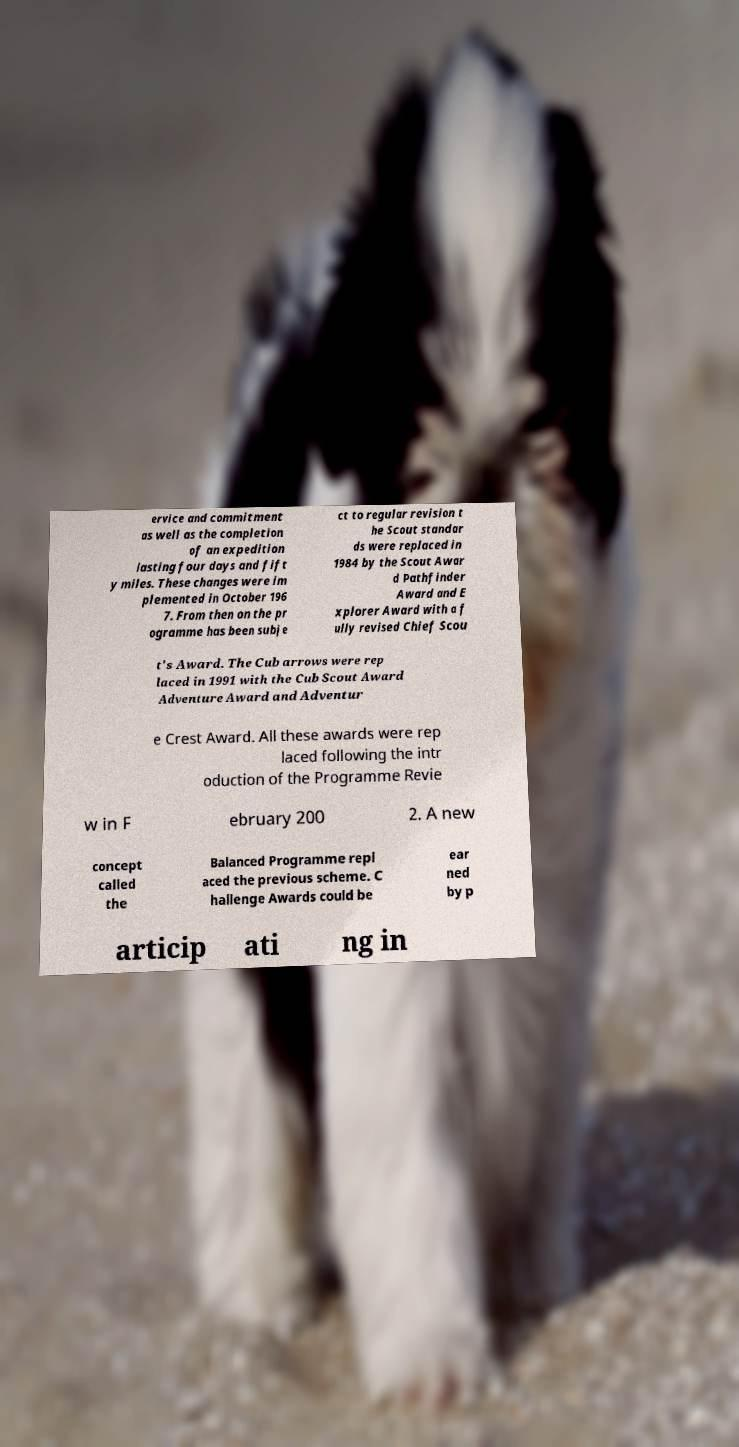Can you accurately transcribe the text from the provided image for me? ervice and commitment as well as the completion of an expedition lasting four days and fift y miles. These changes were im plemented in October 196 7. From then on the pr ogramme has been subje ct to regular revision t he Scout standar ds were replaced in 1984 by the Scout Awar d Pathfinder Award and E xplorer Award with a f ully revised Chief Scou t's Award. The Cub arrows were rep laced in 1991 with the Cub Scout Award Adventure Award and Adventur e Crest Award. All these awards were rep laced following the intr oduction of the Programme Revie w in F ebruary 200 2. A new concept called the Balanced Programme repl aced the previous scheme. C hallenge Awards could be ear ned by p articip ati ng in 